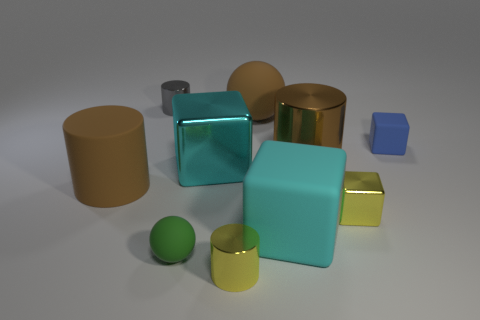Subtract all tiny matte blocks. How many blocks are left? 3 Subtract all blocks. How many objects are left? 6 Subtract all yellow cubes. How many cubes are left? 3 Add 5 metal objects. How many metal objects are left? 10 Add 6 gray things. How many gray things exist? 7 Subtract 0 cyan balls. How many objects are left? 10 Subtract 4 cylinders. How many cylinders are left? 0 Subtract all cyan balls. Subtract all gray cylinders. How many balls are left? 2 Subtract all green spheres. How many cyan cubes are left? 2 Subtract all cyan things. Subtract all large red cylinders. How many objects are left? 8 